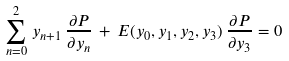Convert formula to latex. <formula><loc_0><loc_0><loc_500><loc_500>\sum _ { n = 0 } ^ { 2 } \, y _ { n + 1 } \, \frac { \partial P } { \partial y _ { n } } \, + \, E ( y _ { 0 } , y _ { 1 } , y _ { 2 } , y _ { 3 } ) \, \frac { \partial P } { \partial y _ { 3 } } = 0</formula> 